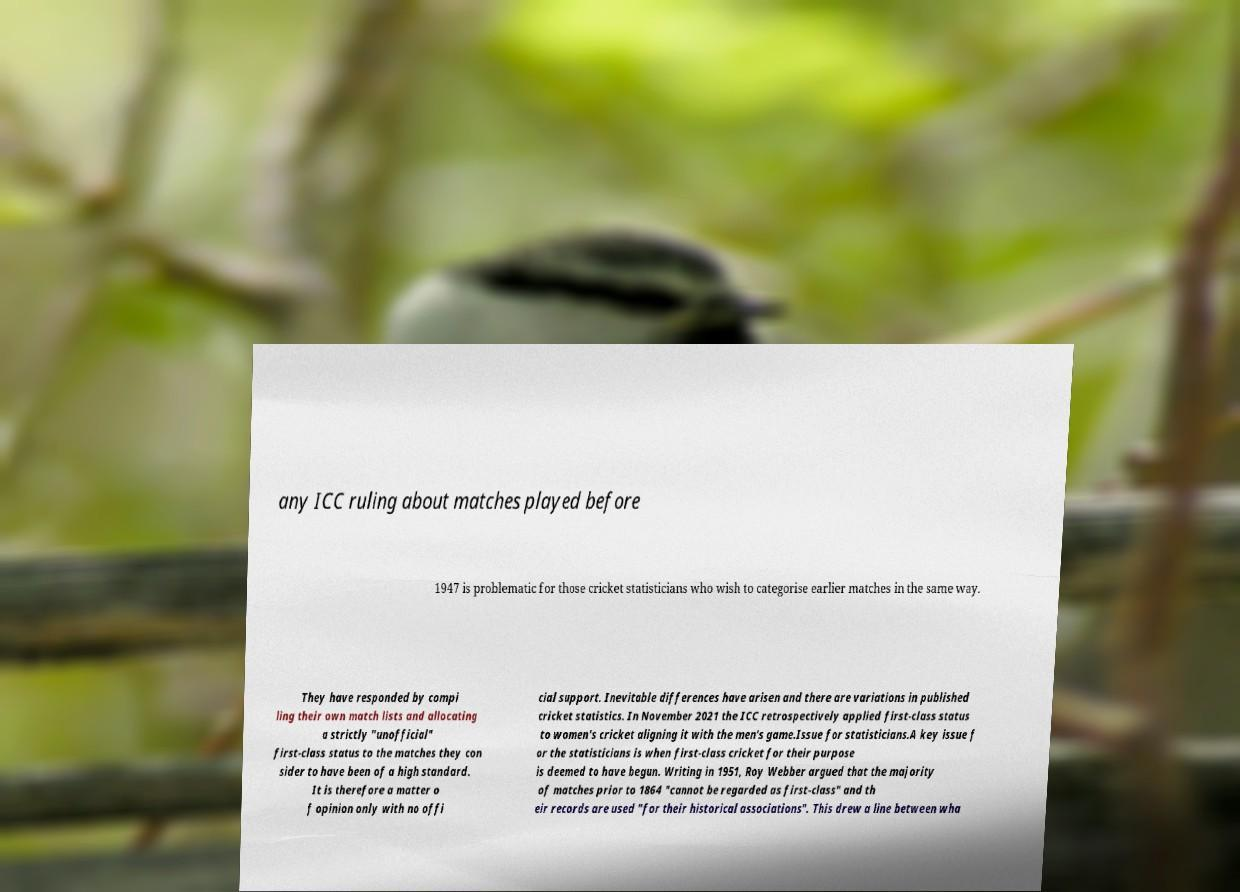I need the written content from this picture converted into text. Can you do that? any ICC ruling about matches played before 1947 is problematic for those cricket statisticians who wish to categorise earlier matches in the same way. They have responded by compi ling their own match lists and allocating a strictly "unofficial" first-class status to the matches they con sider to have been of a high standard. It is therefore a matter o f opinion only with no offi cial support. Inevitable differences have arisen and there are variations in published cricket statistics. In November 2021 the ICC retrospectively applied first-class status to women's cricket aligning it with the men's game.Issue for statisticians.A key issue f or the statisticians is when first-class cricket for their purpose is deemed to have begun. Writing in 1951, Roy Webber argued that the majority of matches prior to 1864 "cannot be regarded as first-class" and th eir records are used "for their historical associations". This drew a line between wha 